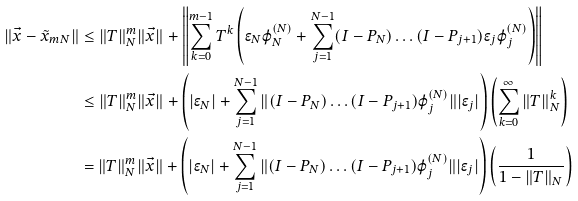Convert formula to latex. <formula><loc_0><loc_0><loc_500><loc_500>\| \vec { x } - \tilde { x } _ { m N } \| & \leq \| T \| _ { N } ^ { m } \| \vec { x } \| + \left \| \sum _ { k = 0 } ^ { m - 1 } T ^ { k } \left ( \epsilon _ { N } \varphi _ { N } ^ { ( N ) } + \sum _ { j = 1 } ^ { N - 1 } ( I - P _ { N } ) \dots ( I - P _ { j + 1 } ) \epsilon _ { j } \varphi _ { j } ^ { ( N ) } \right ) \right \| \\ & \leq \| T \| _ { N } ^ { m } \| \vec { x } \| + \left ( | \epsilon _ { N } | + \sum _ { j = 1 } ^ { N - 1 } \| ( I - P _ { N } ) \dots ( I - P _ { j + 1 } ) \varphi _ { j } ^ { ( N ) } \| | \epsilon _ { j } | \right ) \left ( \sum _ { k = 0 } ^ { \infty } \| T \| ^ { k } _ { N } \right ) \\ & = \| T \| _ { N } ^ { m } \| \vec { x } \| + \left ( | \epsilon _ { N } | + \sum _ { j = 1 } ^ { N - 1 } \| ( I - P _ { N } ) \dots ( I - P _ { j + 1 } ) \varphi _ { j } ^ { ( N ) } \| | \epsilon _ { j } | \right ) \left ( \frac { 1 } { 1 - \| T \| _ { N } } \right ) \\</formula> 